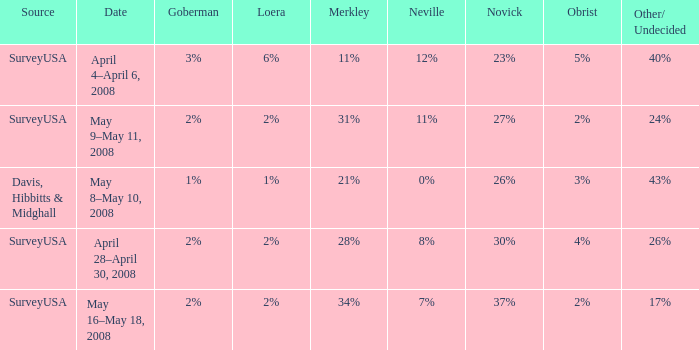Which Loera has a Source of surveyusa, and a Date of may 16–may 18, 2008? 2%. 